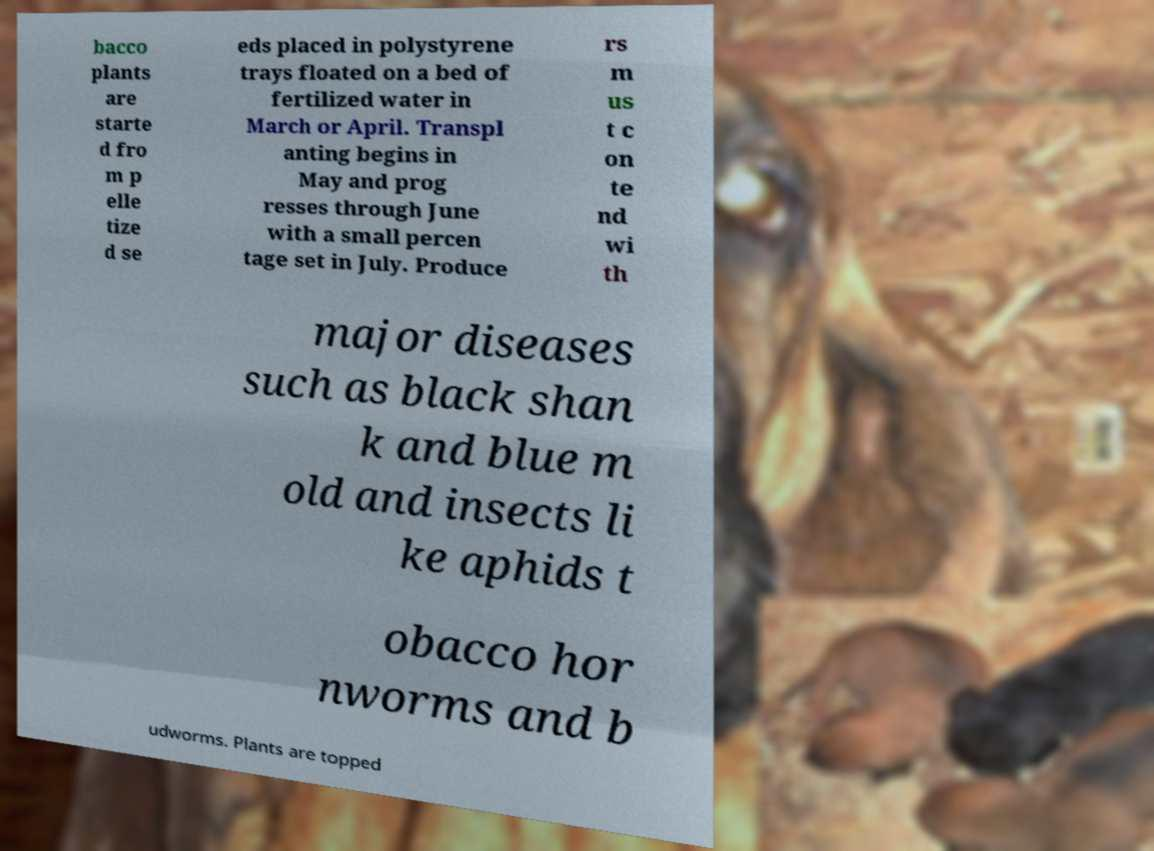For documentation purposes, I need the text within this image transcribed. Could you provide that? bacco plants are starte d fro m p elle tize d se eds placed in polystyrene trays floated on a bed of fertilized water in March or April. Transpl anting begins in May and prog resses through June with a small percen tage set in July. Produce rs m us t c on te nd wi th major diseases such as black shan k and blue m old and insects li ke aphids t obacco hor nworms and b udworms. Plants are topped 